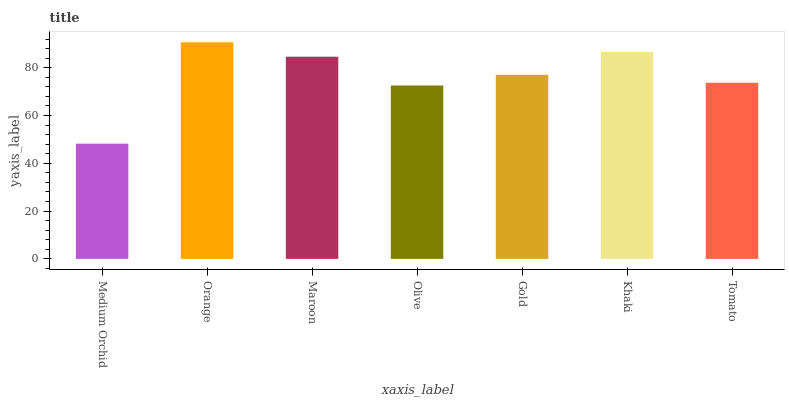Is Maroon the minimum?
Answer yes or no. No. Is Maroon the maximum?
Answer yes or no. No. Is Orange greater than Maroon?
Answer yes or no. Yes. Is Maroon less than Orange?
Answer yes or no. Yes. Is Maroon greater than Orange?
Answer yes or no. No. Is Orange less than Maroon?
Answer yes or no. No. Is Gold the high median?
Answer yes or no. Yes. Is Gold the low median?
Answer yes or no. Yes. Is Orange the high median?
Answer yes or no. No. Is Tomato the low median?
Answer yes or no. No. 